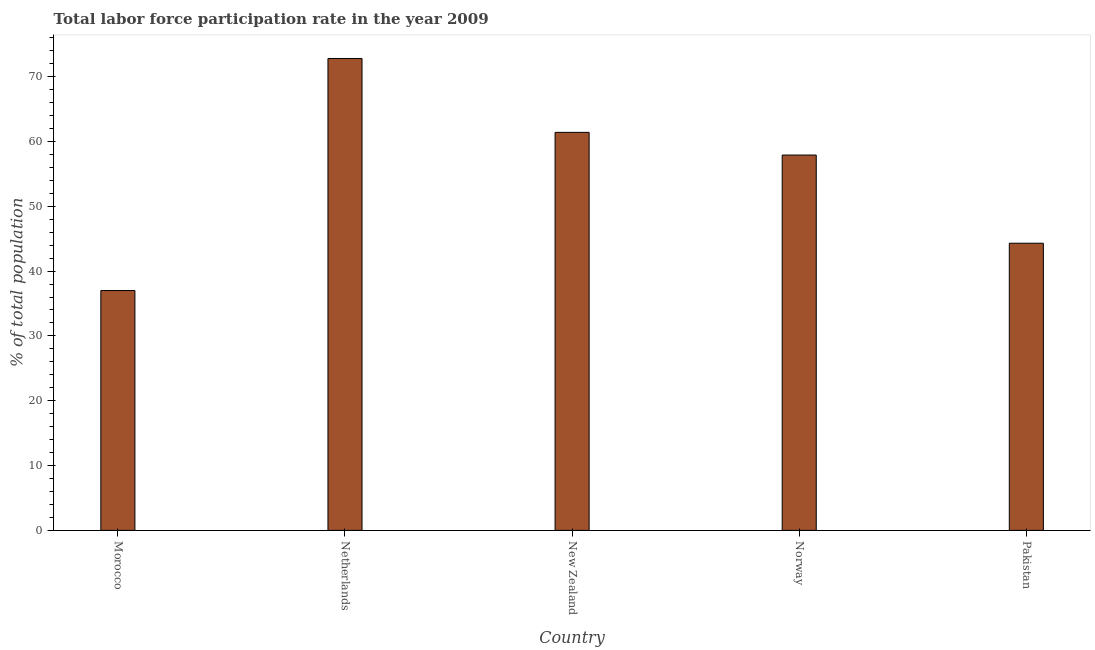Does the graph contain any zero values?
Ensure brevity in your answer.  No. What is the title of the graph?
Ensure brevity in your answer.  Total labor force participation rate in the year 2009. What is the label or title of the Y-axis?
Offer a terse response. % of total population. What is the total labor force participation rate in New Zealand?
Ensure brevity in your answer.  61.4. Across all countries, what is the maximum total labor force participation rate?
Ensure brevity in your answer.  72.8. In which country was the total labor force participation rate minimum?
Provide a short and direct response. Morocco. What is the sum of the total labor force participation rate?
Provide a succinct answer. 273.4. What is the difference between the total labor force participation rate in Morocco and New Zealand?
Your answer should be compact. -24.4. What is the average total labor force participation rate per country?
Give a very brief answer. 54.68. What is the median total labor force participation rate?
Provide a short and direct response. 57.9. In how many countries, is the total labor force participation rate greater than 20 %?
Your response must be concise. 5. What is the ratio of the total labor force participation rate in Morocco to that in New Zealand?
Keep it short and to the point. 0.6. Is the sum of the total labor force participation rate in New Zealand and Norway greater than the maximum total labor force participation rate across all countries?
Give a very brief answer. Yes. What is the difference between the highest and the lowest total labor force participation rate?
Your response must be concise. 35.8. Are all the bars in the graph horizontal?
Ensure brevity in your answer.  No. How many countries are there in the graph?
Ensure brevity in your answer.  5. What is the difference between two consecutive major ticks on the Y-axis?
Offer a very short reply. 10. Are the values on the major ticks of Y-axis written in scientific E-notation?
Ensure brevity in your answer.  No. What is the % of total population in Morocco?
Your answer should be very brief. 37. What is the % of total population in Netherlands?
Your response must be concise. 72.8. What is the % of total population in New Zealand?
Your answer should be very brief. 61.4. What is the % of total population in Norway?
Give a very brief answer. 57.9. What is the % of total population of Pakistan?
Your answer should be compact. 44.3. What is the difference between the % of total population in Morocco and Netherlands?
Provide a short and direct response. -35.8. What is the difference between the % of total population in Morocco and New Zealand?
Give a very brief answer. -24.4. What is the difference between the % of total population in Morocco and Norway?
Offer a terse response. -20.9. What is the difference between the % of total population in Netherlands and New Zealand?
Your response must be concise. 11.4. What is the difference between the % of total population in Netherlands and Norway?
Your answer should be very brief. 14.9. What is the difference between the % of total population in Netherlands and Pakistan?
Offer a very short reply. 28.5. What is the difference between the % of total population in New Zealand and Norway?
Keep it short and to the point. 3.5. What is the difference between the % of total population in New Zealand and Pakistan?
Provide a short and direct response. 17.1. What is the ratio of the % of total population in Morocco to that in Netherlands?
Ensure brevity in your answer.  0.51. What is the ratio of the % of total population in Morocco to that in New Zealand?
Your answer should be compact. 0.6. What is the ratio of the % of total population in Morocco to that in Norway?
Provide a short and direct response. 0.64. What is the ratio of the % of total population in Morocco to that in Pakistan?
Your answer should be compact. 0.83. What is the ratio of the % of total population in Netherlands to that in New Zealand?
Give a very brief answer. 1.19. What is the ratio of the % of total population in Netherlands to that in Norway?
Your answer should be compact. 1.26. What is the ratio of the % of total population in Netherlands to that in Pakistan?
Give a very brief answer. 1.64. What is the ratio of the % of total population in New Zealand to that in Norway?
Make the answer very short. 1.06. What is the ratio of the % of total population in New Zealand to that in Pakistan?
Offer a terse response. 1.39. What is the ratio of the % of total population in Norway to that in Pakistan?
Your answer should be very brief. 1.31. 